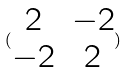Convert formula to latex. <formula><loc_0><loc_0><loc_500><loc_500>( \begin{matrix} 2 & - 2 \\ - 2 & 2 \end{matrix} )</formula> 